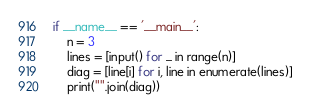<code> <loc_0><loc_0><loc_500><loc_500><_Python_>if __name__ == '__main__':
    n = 3
    lines = [input() for _ in range(n)]
    diag = [line[i] for i, line in enumerate(lines)]
    print("".join(diag))
</code> 